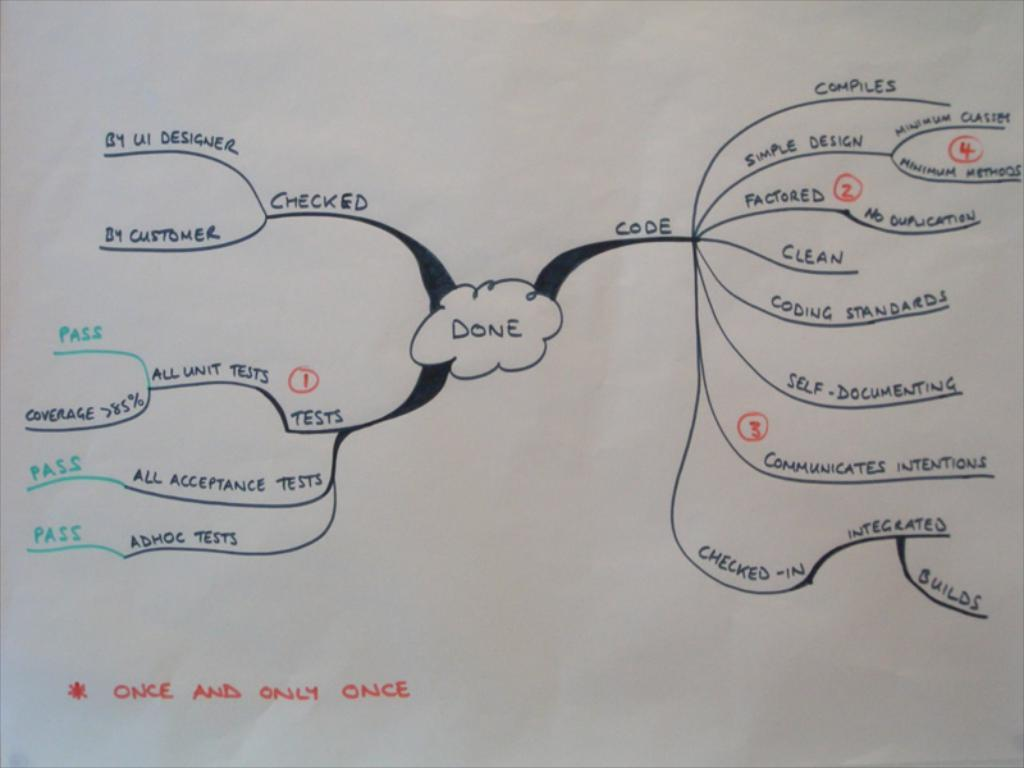<image>
Describe the image concisely. A chart is drawn out on a white piece of paper and at the bottom it says "Once and only once" 